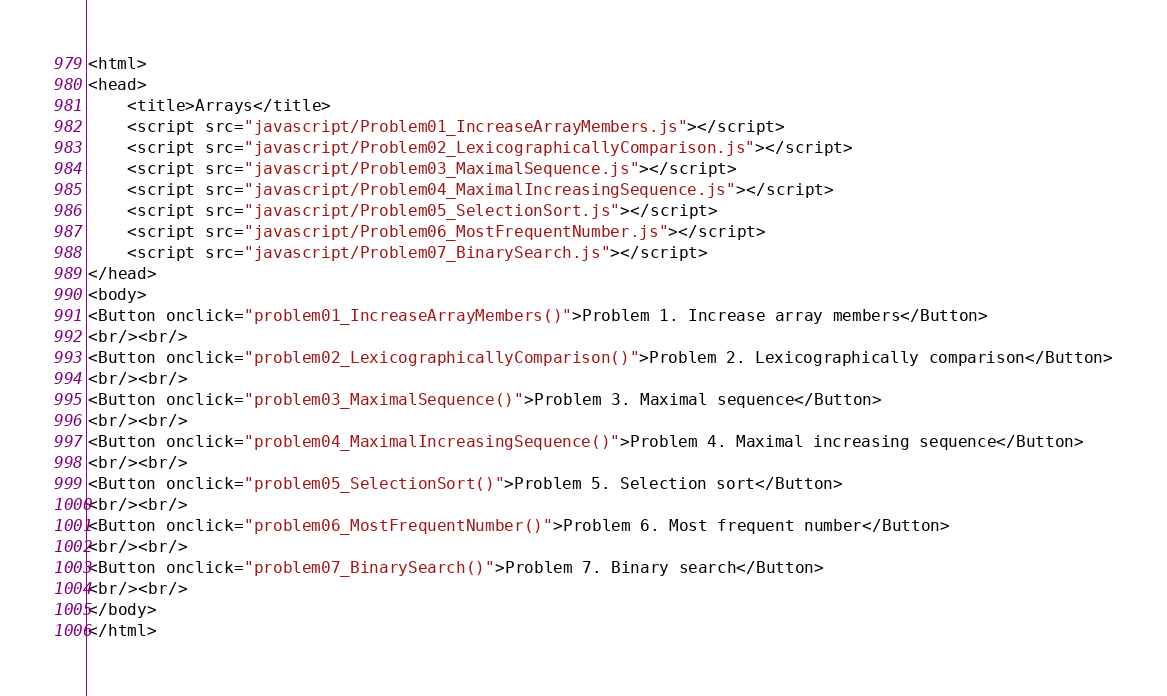<code> <loc_0><loc_0><loc_500><loc_500><_HTML_><html>
<head>
    <title>Arrays</title>
    <script src="javascript/Problem01_IncreaseArrayMembers.js"></script>
    <script src="javascript/Problem02_LexicographicallyComparison.js"></script>
    <script src="javascript/Problem03_MaximalSequence.js"></script>
    <script src="javascript/Problem04_MaximalIncreasingSequence.js"></script>
    <script src="javascript/Problem05_SelectionSort.js"></script>
    <script src="javascript/Problem06_MostFrequentNumber.js"></script>
    <script src="javascript/Problem07_BinarySearch.js"></script>
</head>
<body>
<Button onclick="problem01_IncreaseArrayMembers()">Problem 1. Increase array members</Button>
<br/><br/>
<Button onclick="problem02_LexicographicallyComparison()">Problem 2. Lexicographically comparison</Button>
<br/><br/>
<Button onclick="problem03_MaximalSequence()">Problem 3. Maximal sequence</Button>
<br/><br/>
<Button onclick="problem04_MaximalIncreasingSequence()">Problem 4. Maximal increasing sequence</Button>
<br/><br/>
<Button onclick="problem05_SelectionSort()">Problem 5. Selection sort</Button>
<br/><br/>
<Button onclick="problem06_MostFrequentNumber()">Problem 6. Most frequent number</Button>
<br/><br/>
<Button onclick="problem07_BinarySearch()">Problem 7. Binary search</Button>
<br/><br/>
</body>
</html></code> 